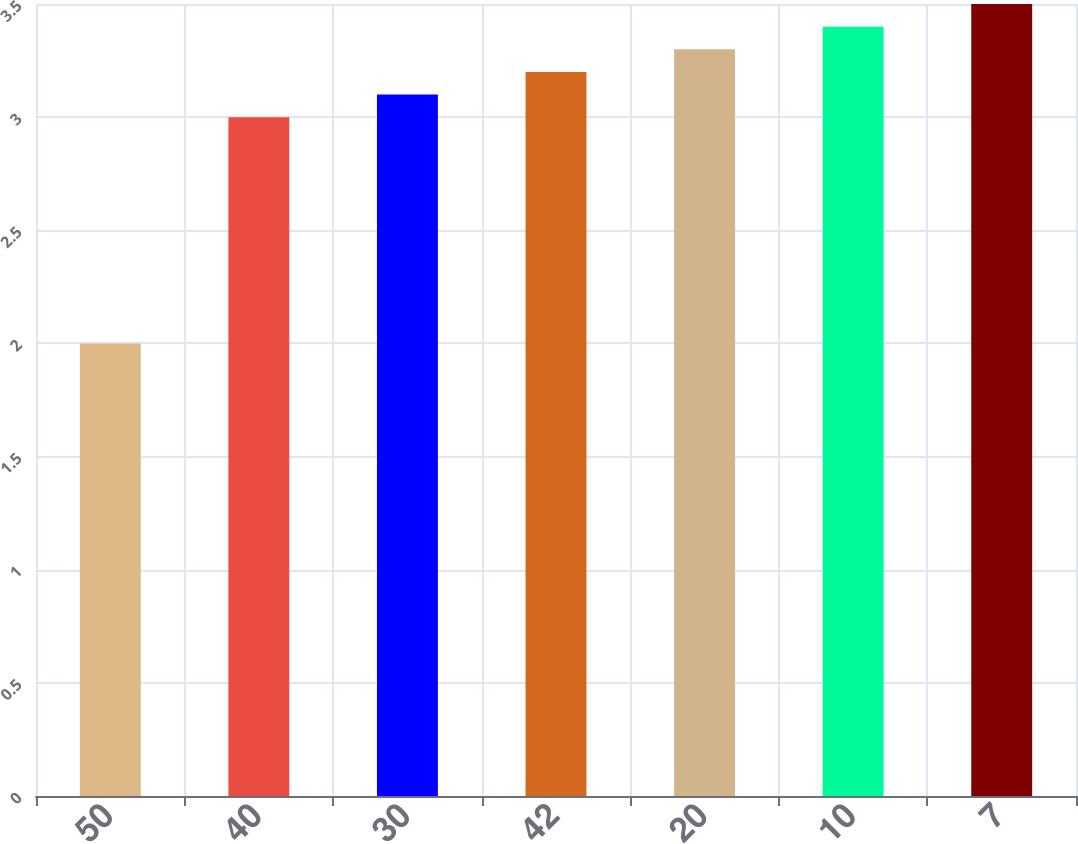Convert chart to OTSL. <chart><loc_0><loc_0><loc_500><loc_500><bar_chart><fcel>50<fcel>40<fcel>30<fcel>42<fcel>20<fcel>10<fcel>7<nl><fcel>2<fcel>3<fcel>3.1<fcel>3.2<fcel>3.3<fcel>3.4<fcel>3.5<nl></chart> 